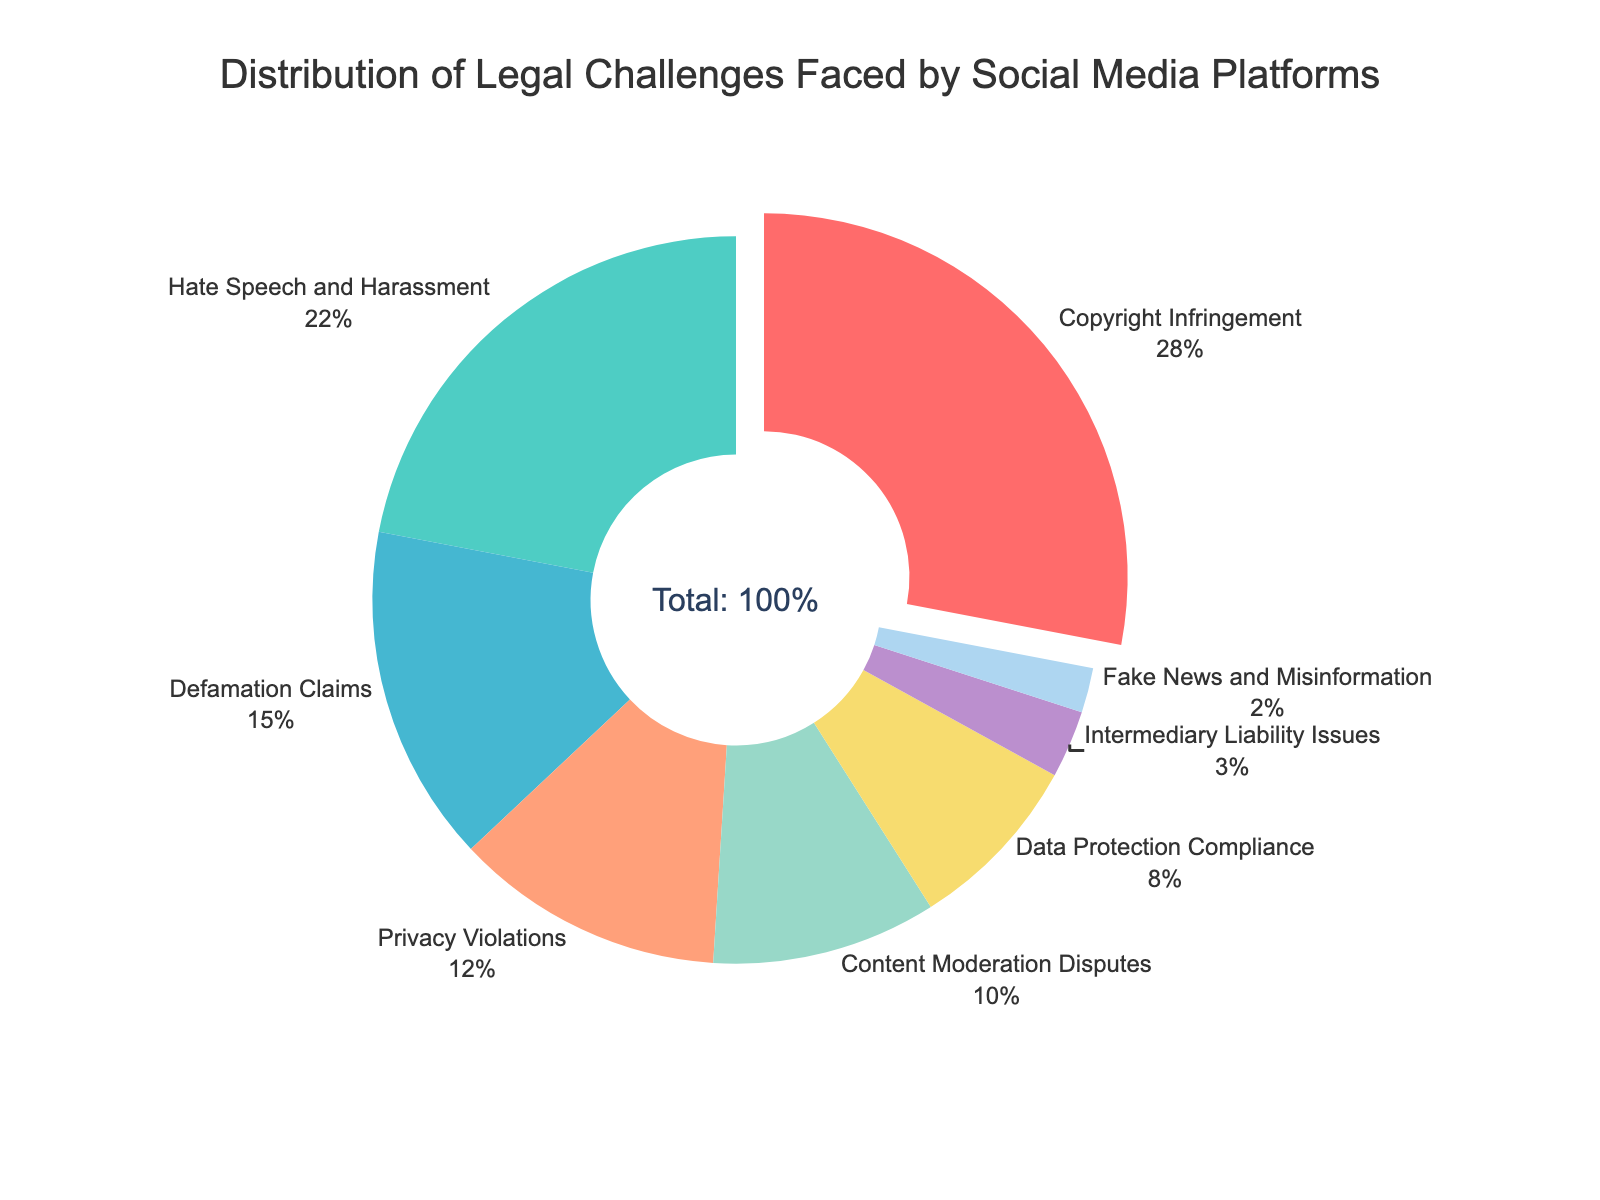Which category faces the highest percentage of legal challenges? The category with the highest percentage of legal challenges is highlighted by its pull-out position in the pie chart, which should be easily visible. Additionally, looking at the label percentages, the largest value should match with the highlighted segment.
Answer: Copyright Infringement Which two categories together account for more than 50% of legal challenges? First, identify the two highest percentages in the pie chart, which are Copyright Infringement (28%) and Hate Speech and Harassment (22%). Adding these percentages together (28% + 22%) gives a total of 50%. However, since it specifically mentions more than 50%, we need to add the next highest category. Adding Defamation Claims (15%) to 28% and 22% yields 65%, which is more than 50%.
Answer: Copyright Infringement and Hate Speech and Harassment What is the combined percentage for Privacy Violations and Data Protection Compliance? Identify the percentages for Privacy Violations (12%) and Data Protection Compliance (8%) on the pie chart. Add these two percentages together (12% + 8%).
Answer: 20% Which category has the smallest percentage of legal challenges? The category with the smallest percentage should be identified by looking for the smallest label in the pie chart, which also might be least noticeable visually.
Answer: Fake News and Misinformation How does the percentage of Defamation Claims compare to Content Moderation Disputes? Identify the percentages for Defamation Claims (15%) and Content Moderation Disputes (10%). Comparing these values, 15% is larger than 10%.
Answer: Defamation Claims are 5% higher What is the difference in percentage between Hate Speech and Harassment and Intermediary Liability Issues? Identify the percentages for Hate Speech and Harassment (22%) and Intermediary Liability Issues (3%). Subtract the smaller percentage from the larger one (22% - 3%).
Answer: 19% Which categories are visualized using shades of blue? Visually identify the segments in the pie chart that are colored blue. Based on the provided color palette, the shades of blue are likely used for specific categories.
Answer: Defamation Claims and Data Protection Compliance What percentage of challenges are related to content issues (Copyright Infringement, Hate Speech and Harassment, Content Moderation Disputes, Fake News and Misinformation)? Identify and sum the percentages for content-related categories: Copyright Infringement (28%), Hate Speech and Harassment (22%), Content Moderation Disputes (10%), and Fake News and Misinformation (2%). The total is (28% + 22% + 10% + 2%).
Answer: 62% Which category is shown with a green color, and what is its percentage? Find the segment in the pie chart that is green. Cross-reference this with the legend or labels to identify the category and its percentage.
Answer: Hate Speech and Harassment, 22% What would the percentage be if Data Protection Compliance and Intermediary Liability Issues were combined? Add the percentages of Data Protection Compliance (8%) and Intermediary Liability Issues (3%). The sum is (8% + 3%).
Answer: 11% 